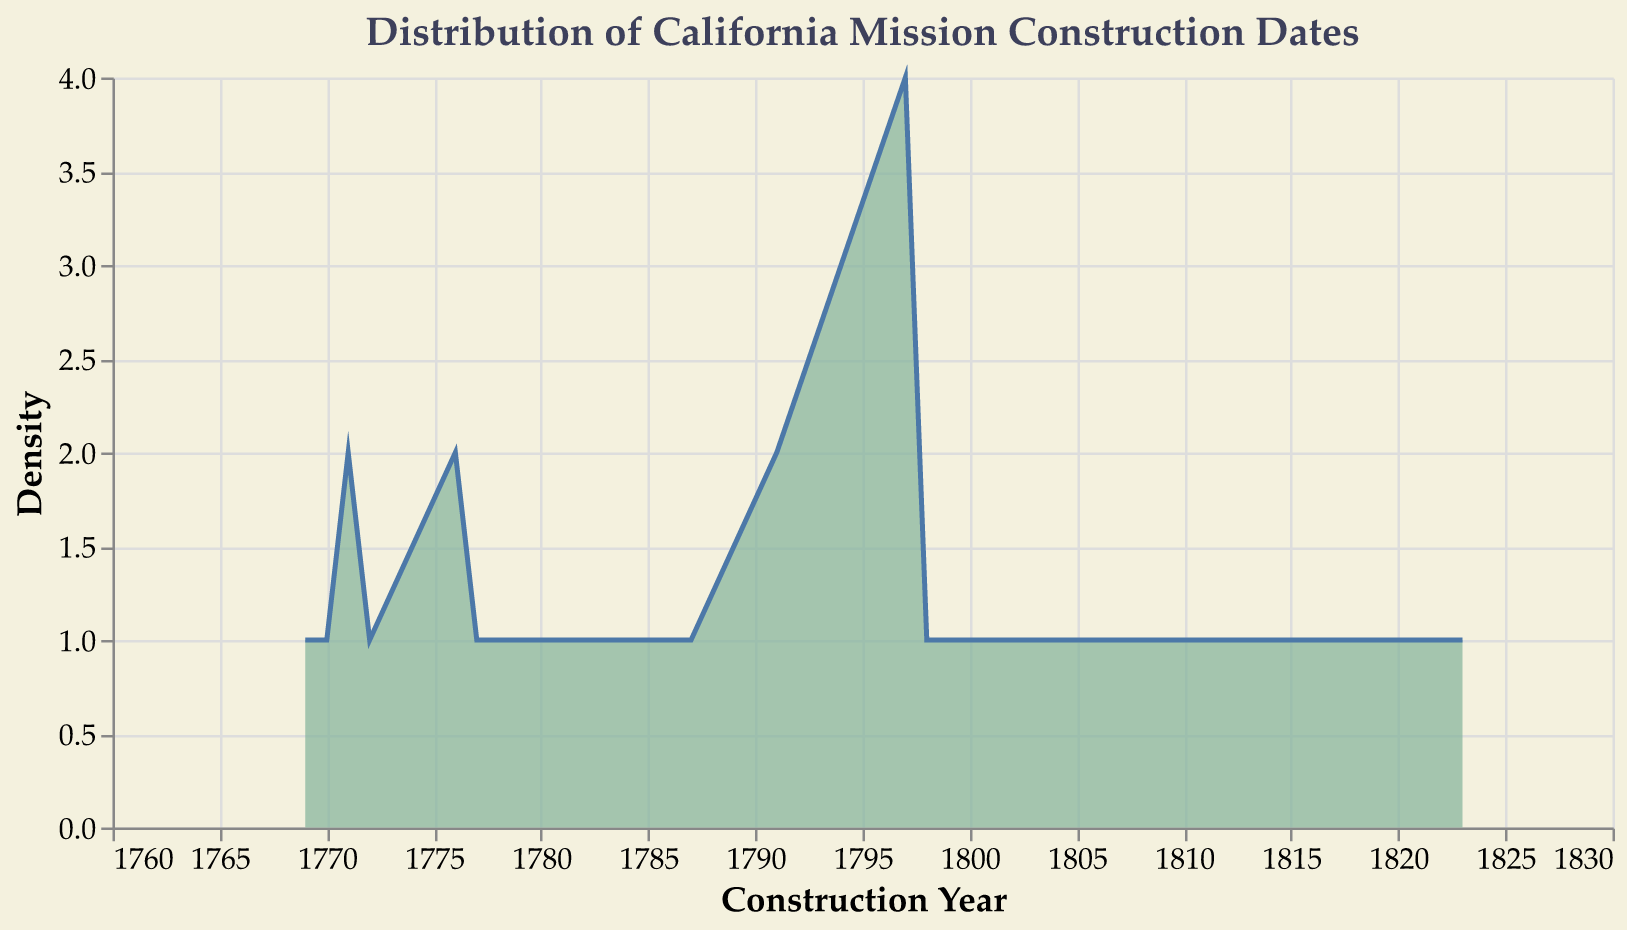What is the title of the density plot? The title is typically found at the top of the plot and describes the data being visualized. In this case, it should match the plot's topic.
Answer: Distribution of California Mission Construction Dates What is the time range shown on the x-axis? The x-axis represents the timeline of construction dates. By examining the axis labels, we can determine the range.
Answer: 1760 to 1830 How many missions were constructed in 1797? By finding the peak around 1797 on the density plot, you can count the corresponding density. The peak at 1797 shows a density representative of the number of constructions at that time.
Answer: 5 In which year was there the highest density of mission constructions? By looking at the peak of the density plot, we can identify the year with the highest frequency of constructions.
Answer: 1797 What is the color used to fill the area under the density plot? The color of the area under the curve is directly observed from the visual attributes of the plot.
Answer: Light green Which time period had more mission constructions: the 1770s or the 1790s? By comparing the areas under the curve for both periods, you can see a higher density around the 1790s than the 1770s.
Answer: 1790s How can you tell the density at a specific Construction Date on this plot? The density at a specific year is determined by the height of the plot curve at that year. The y-axis values represent the density.
Answer: By the height of the curve How many peaks are there in the density plot? By observing the curve, you can count the number of prominent peaks that represent periods with high frequencies of constructions.
Answer: 3 What’s the density of missions constructed in 1804 compared to 1817? By comparing the height of the curves at 1804 and 1817, you can determine which year had a higher density of constructions.
Answer: Higher in 1804 than in 1817 How does the density in the 1760s compare with the 1780s? By comparing the area under the curve for the two decades, you can assess the relative frequencies of constructions.
Answer: Lower in the 1760s than in the 1780s 